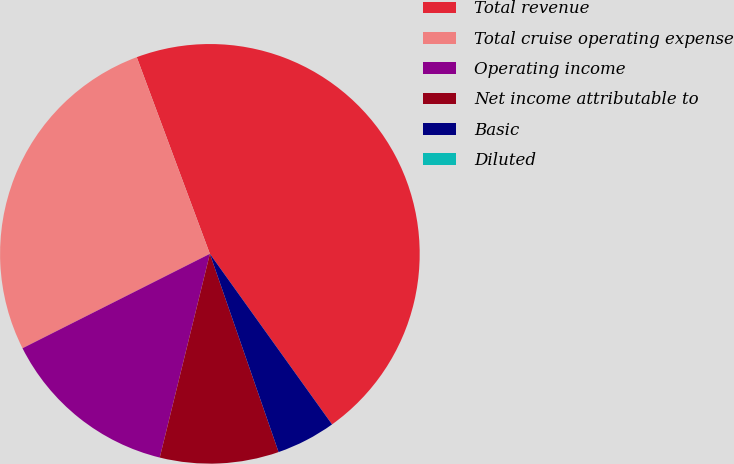<chart> <loc_0><loc_0><loc_500><loc_500><pie_chart><fcel>Total revenue<fcel>Total cruise operating expense<fcel>Operating income<fcel>Net income attributable to<fcel>Basic<fcel>Diluted<nl><fcel>45.77%<fcel>26.76%<fcel>13.73%<fcel>9.15%<fcel>4.58%<fcel>0.0%<nl></chart> 